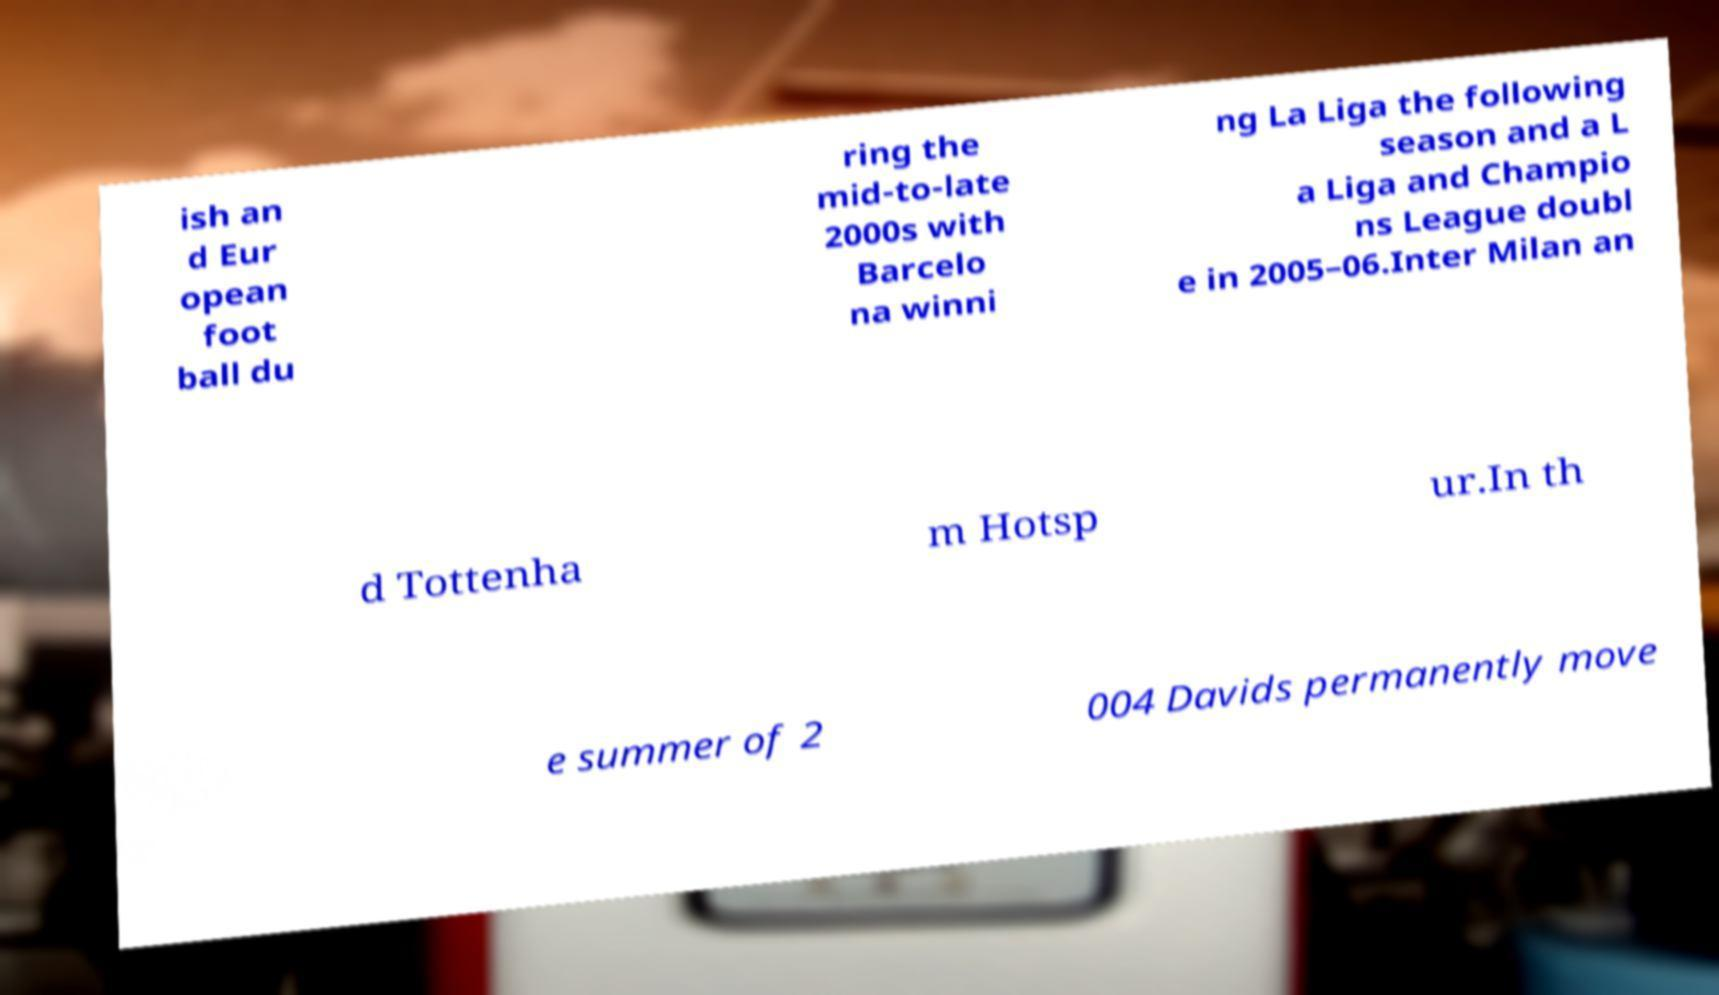What messages or text are displayed in this image? I need them in a readable, typed format. ish an d Eur opean foot ball du ring the mid-to-late 2000s with Barcelo na winni ng La Liga the following season and a L a Liga and Champio ns League doubl e in 2005–06.Inter Milan an d Tottenha m Hotsp ur.In th e summer of 2 004 Davids permanently move 